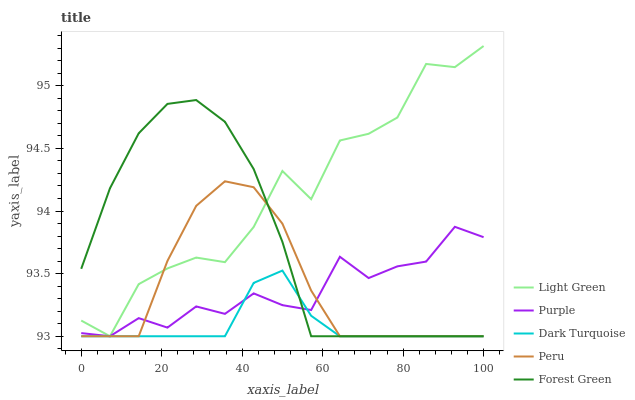Does Dark Turquoise have the minimum area under the curve?
Answer yes or no. Yes. Does Light Green have the maximum area under the curve?
Answer yes or no. Yes. Does Forest Green have the minimum area under the curve?
Answer yes or no. No. Does Forest Green have the maximum area under the curve?
Answer yes or no. No. Is Dark Turquoise the smoothest?
Answer yes or no. Yes. Is Light Green the roughest?
Answer yes or no. Yes. Is Forest Green the smoothest?
Answer yes or no. No. Is Forest Green the roughest?
Answer yes or no. No. Does Purple have the lowest value?
Answer yes or no. Yes. Does Light Green have the highest value?
Answer yes or no. Yes. Does Forest Green have the highest value?
Answer yes or no. No. Does Dark Turquoise intersect Forest Green?
Answer yes or no. Yes. Is Dark Turquoise less than Forest Green?
Answer yes or no. No. Is Dark Turquoise greater than Forest Green?
Answer yes or no. No. 